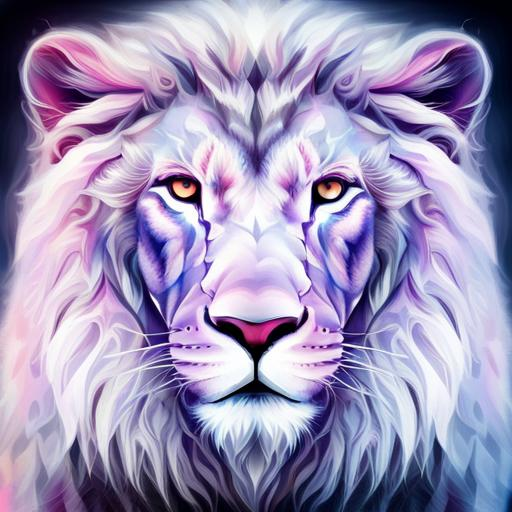What feelings or ideas might the colors in this image be trying to convey? The use of cool and warm tones in the image could be symbolizing a duality or balance of forces, with the cooler purples and blues perhaps representing calmness and serenity, while the warmer oranges and yellows might evoke strength and passion. Together, they seem to infuse the lion with a mystical or otherworldly essence. 